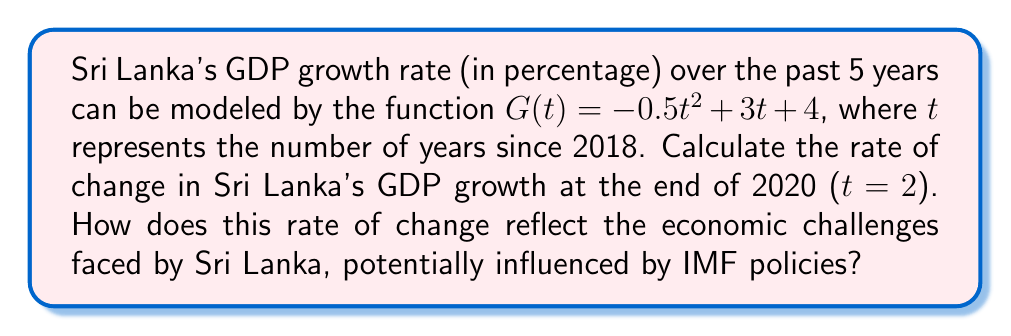What is the answer to this math problem? To solve this problem, we need to follow these steps:

1) The rate of change in GDP growth is represented by the derivative of the function G(t).

2) To find the derivative, we use the power rule:
   $$G'(t) = -0.5 \cdot 2t + 3 = -t + 3$$

3) We're asked to find the rate of change at t = 2 (end of 2020):
   $$G'(2) = -(2) + 3 = -2 + 3 = 1$$

4) Interpretation: The rate of change is positive (1% per year), indicating that GDP growth was still increasing at the end of 2020, but at a decreasing rate compared to previous years. This slowing growth could reflect economic challenges, potentially exacerbated by IMF-recommended austerity measures or structural adjustments.
Answer: 1% per year 